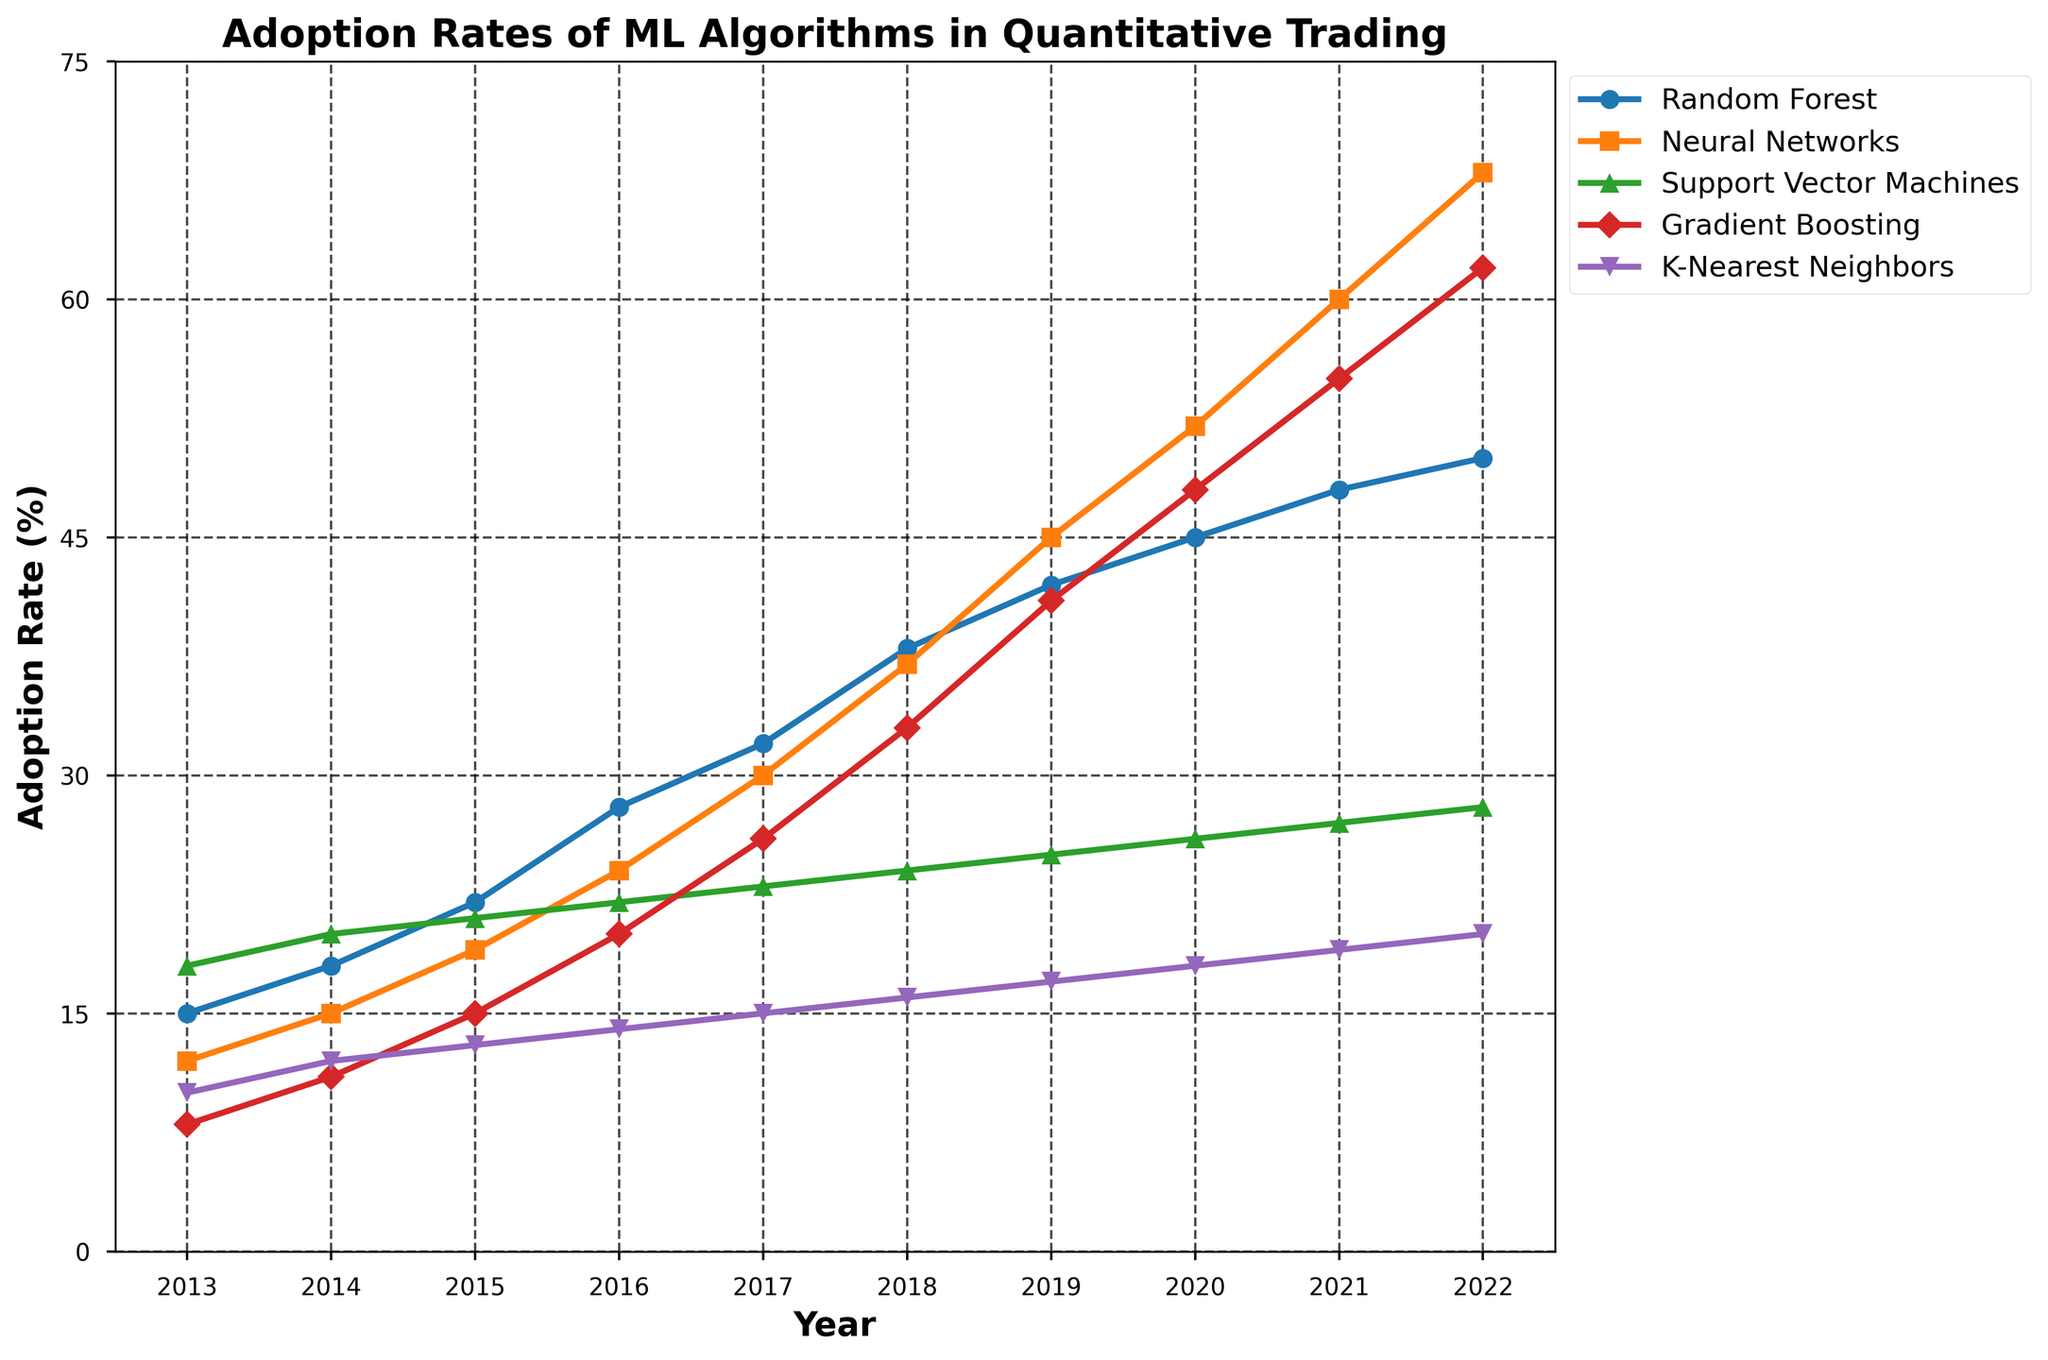What year saw the highest adoption rate of Neural Networks? Identify the highest data point in the Neural Networks line and note the corresponding year
Answer: 2022 Which algorithm had the lowest adoption rate in 2013? Compare adoption rates of all algorithms for the year 2013, and identify the lowest value
Answer: Gradient Boosting How did the adoption rate of Random Forests change from 2013 to 2014? Subtract the adoption rate in 2013 from that in 2014
Answer: Increased by 3% Which two algorithms had an equal adoption rate in any given year? Scan through the lines to find instances where two lines intersect or are equal
Answer: No algorithms had equal adoption rates in any given year What is the average adoption rate of K-Nearest Neighbors over the decade? Sum the adoption rates of K-Nearest Neighbors from 2013 to 2022, then divide by the number of years (10)
Answer: (10 + 12 + 13 + 14 + 15 + 16 + 17 + 18 + 19 + 20) / 10 = 15.4% Which algorithm experienced the most substantial growth in adoption rate from 2013 to 2022? Compute the difference in adoption rates for each algorithm between 2013 and 2022 and identify the largest value
Answer: Neural Networks In 2019, which algorithm had the second highest adoption rate? Arrange the adoption rates of all algorithms in 2019 in descending order and find the second largest value
Answer: Neural Networks How much did the adoption rate of Gradient Boosting increase from 2016 to 2022? Subtract the adoption rate in 2016 from that in 2022
Answer: 62% - 20% = 42% Between 2015 and 2018, which year had the highest overall adoption rate across all algorithms? Sum the adoption rates of all algorithms for each year between 2015 and 2018 and identify the highest sum
Answer: 2018 What is the ratio of the adoption rate of Support Vector Machines to Gradient Boosting in 2021? Divide the adoption rate of Support Vector Machines by the adoption rate of Gradient Boosting in 2021
Answer: 27 / 55 = 0.49 